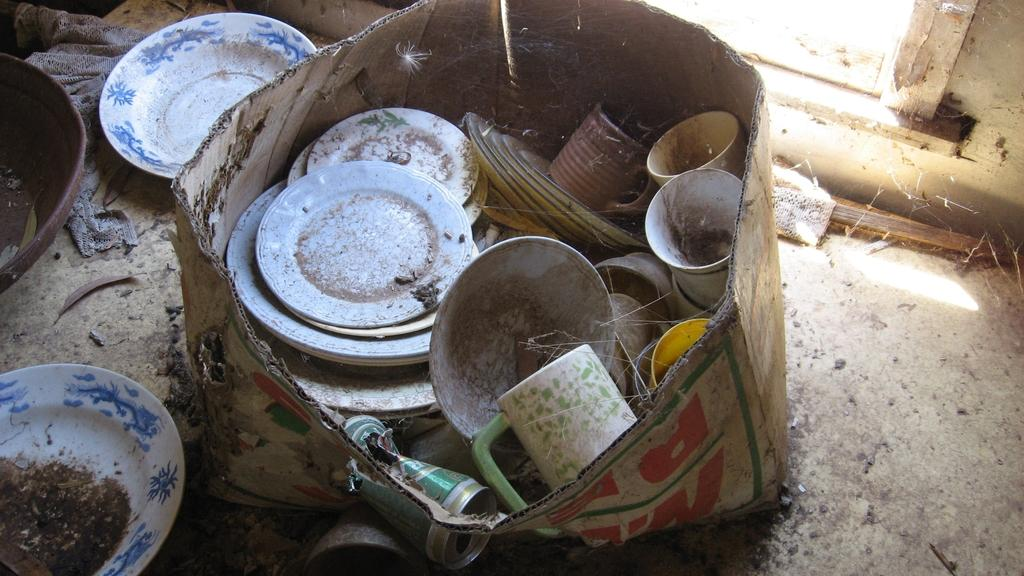What is on the floor in the image? There is a cardboard box on the floor. What can be found inside the cardboard box? Inside the box, there are plates, cups, and other items. Are there any plates visible outside of the box? Yes, there are plates on the floor. What other items can be seen on the floor? There are other items on the floor besides the plates. Can you see any cracks or cobwebs on the elbow of the person in the image? There is no person present in the image, so it is not possible to see any cracks or cobwebs on their elbow. 